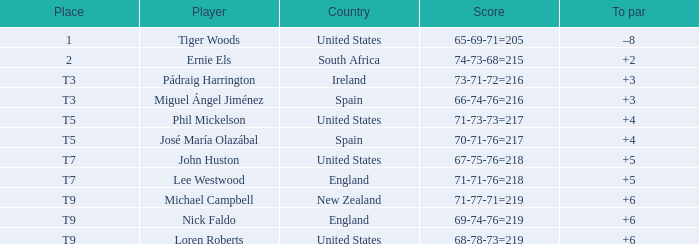What is to par when spot is "t5" and when country is "united states"? 4.0. 